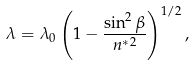<formula> <loc_0><loc_0><loc_500><loc_500>\lambda = \lambda _ { 0 } \left ( 1 - \frac { \sin ^ { 2 } \beta } { n ^ { * 2 } } \right ) ^ { 1 / 2 } ,</formula> 